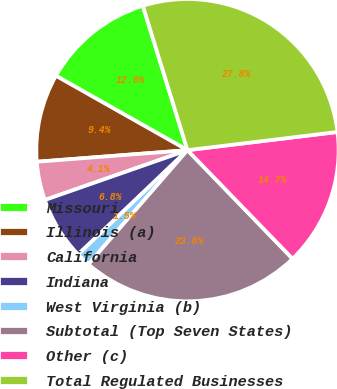Convert chart. <chart><loc_0><loc_0><loc_500><loc_500><pie_chart><fcel>Missouri<fcel>Illinois (a)<fcel>California<fcel>Indiana<fcel>West Virginia (b)<fcel>Subtotal (Top Seven States)<fcel>Other (c)<fcel>Total Regulated Businesses<nl><fcel>12.04%<fcel>9.41%<fcel>4.13%<fcel>6.77%<fcel>1.5%<fcel>23.62%<fcel>14.68%<fcel>27.85%<nl></chart> 